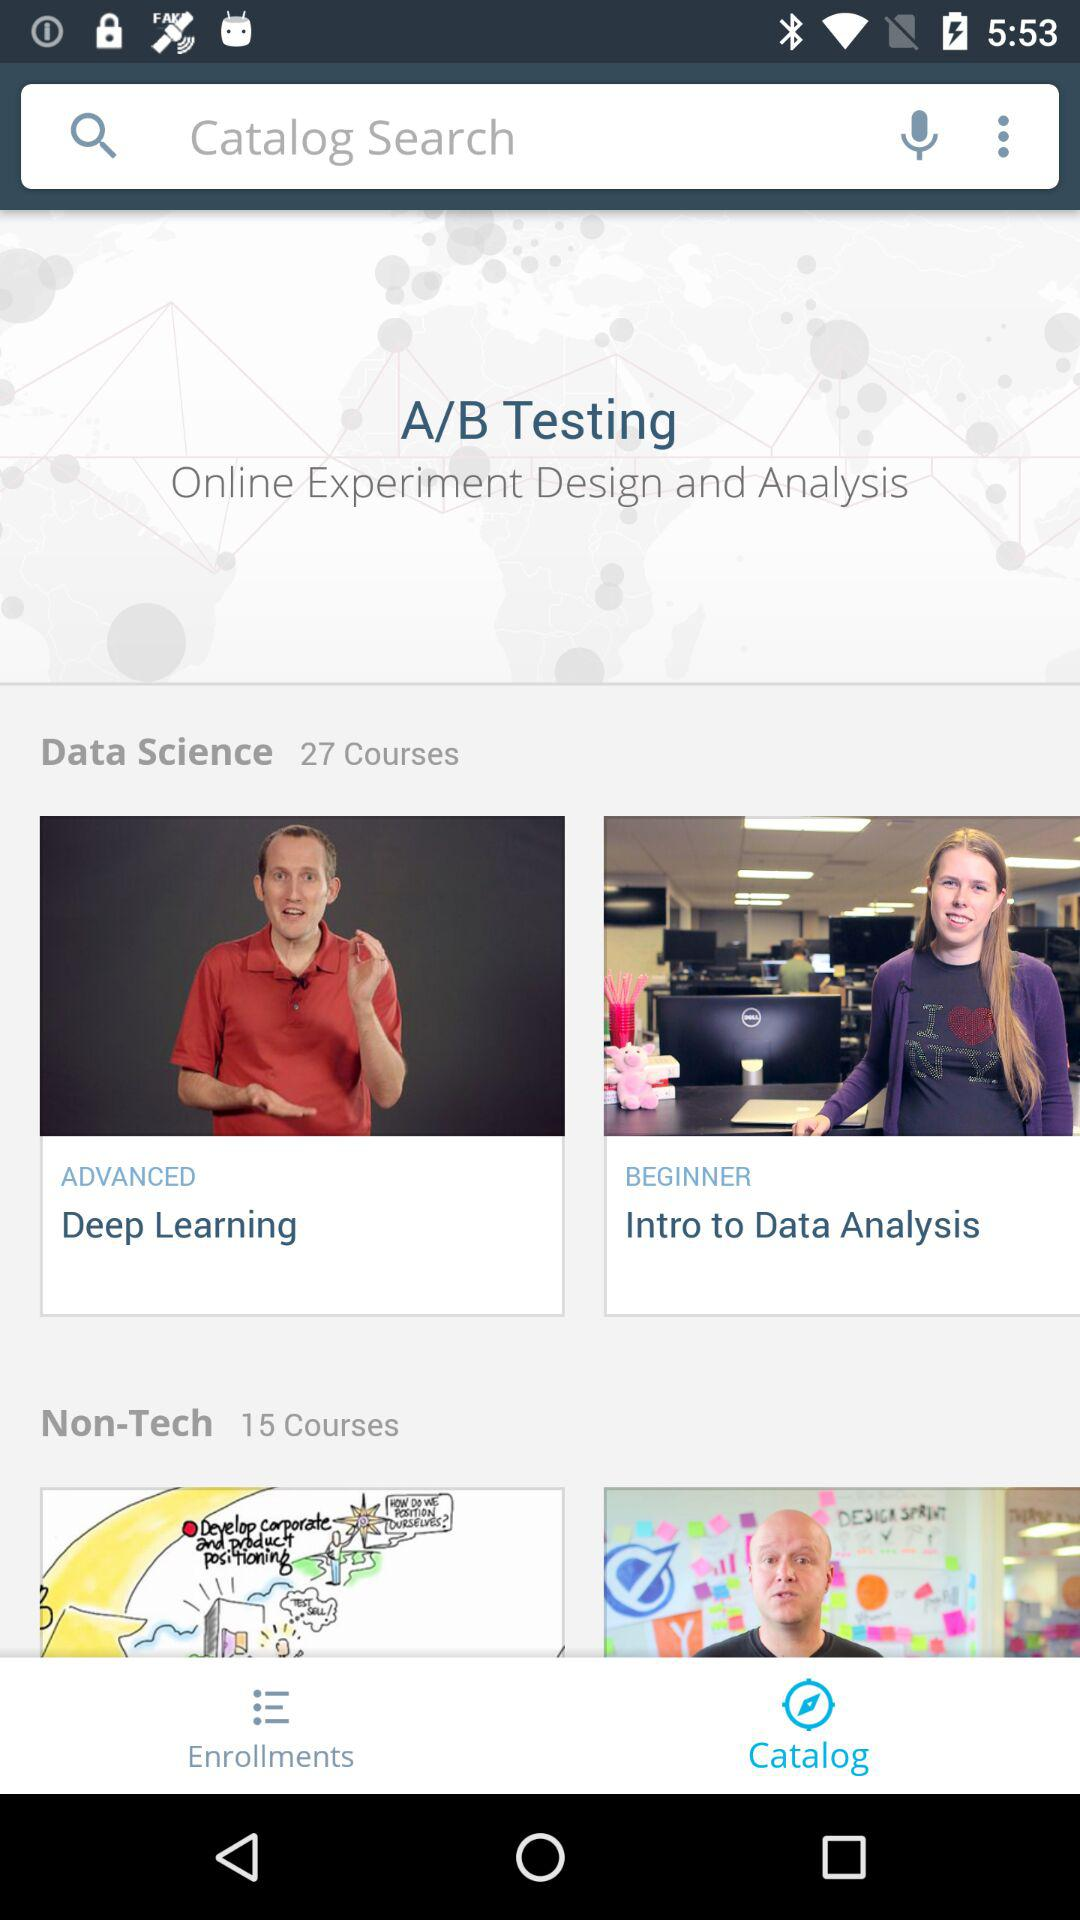How many more courses are in the Non-Tech category than the Data Science category?
Answer the question using a single word or phrase. 12 